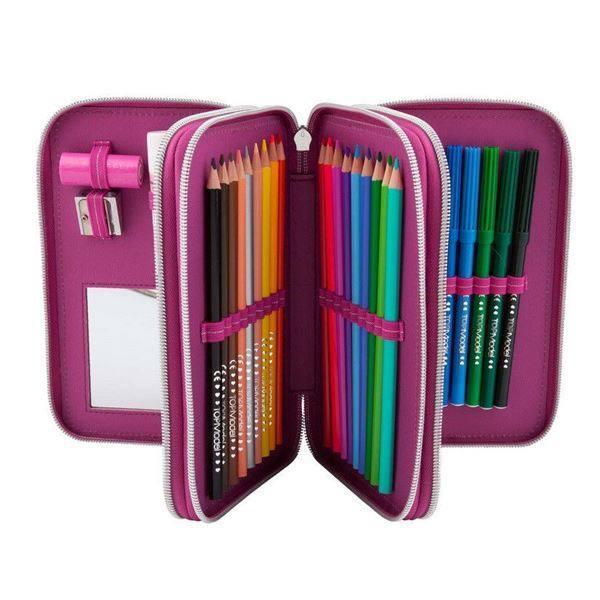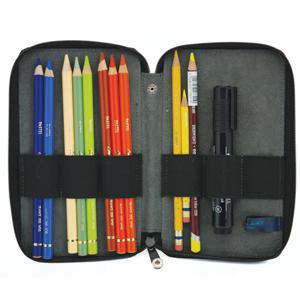The first image is the image on the left, the second image is the image on the right. Evaluate the accuracy of this statement regarding the images: "One of the images shows a pencil case with a ruler inside.". Is it true? Answer yes or no. No. The first image is the image on the left, the second image is the image on the right. Analyze the images presented: Is the assertion "The open, filled pencil case on the left has at least one inner compartment that fans out, while the filled case on the right has only a front and back and opens like a clamshell." valid? Answer yes or no. Yes. 